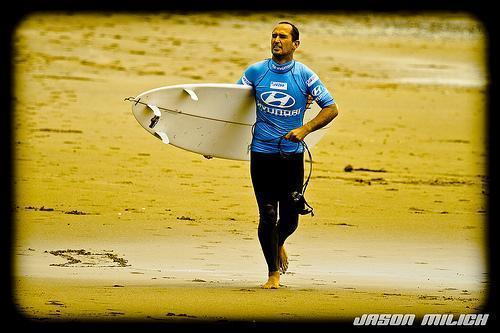How many fins are on the board?
Give a very brief answer. 3. 